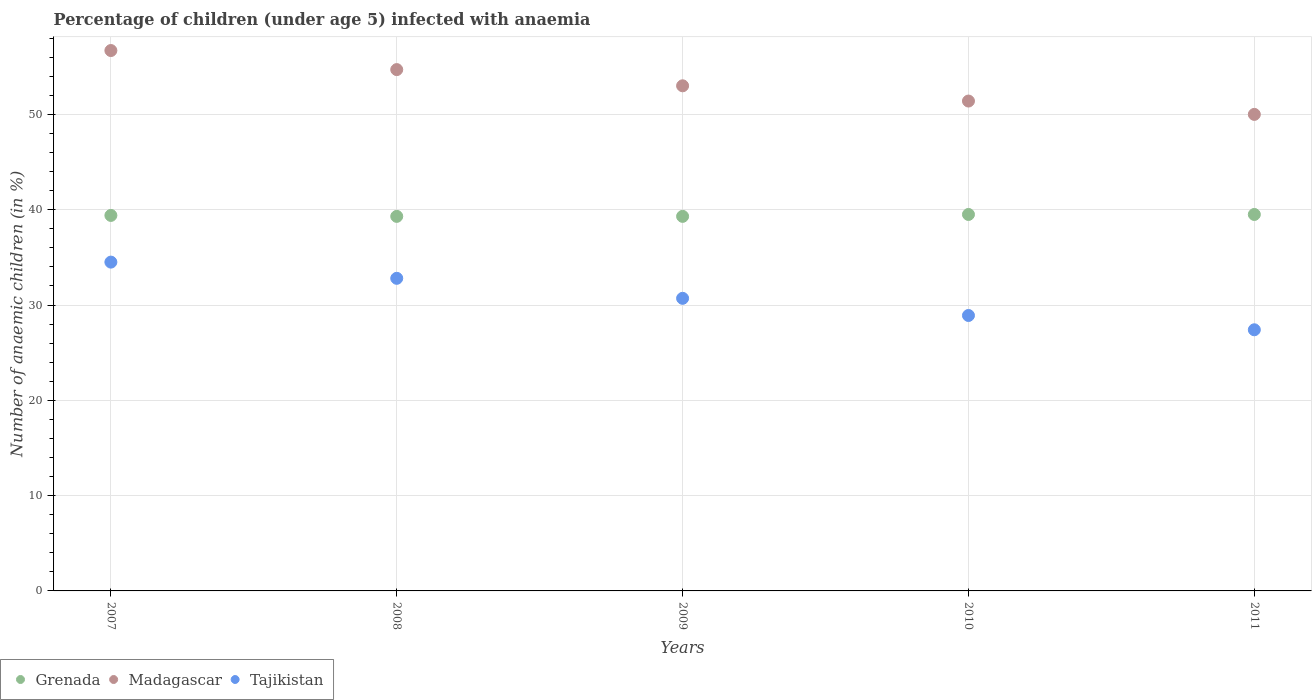How many different coloured dotlines are there?
Ensure brevity in your answer.  3. Is the number of dotlines equal to the number of legend labels?
Give a very brief answer. Yes. What is the percentage of children infected with anaemia in in Grenada in 2010?
Keep it short and to the point. 39.5. Across all years, what is the maximum percentage of children infected with anaemia in in Madagascar?
Your response must be concise. 56.7. Across all years, what is the minimum percentage of children infected with anaemia in in Madagascar?
Give a very brief answer. 50. What is the total percentage of children infected with anaemia in in Tajikistan in the graph?
Offer a terse response. 154.3. What is the difference between the percentage of children infected with anaemia in in Tajikistan in 2009 and that in 2010?
Provide a short and direct response. 1.8. What is the difference between the percentage of children infected with anaemia in in Grenada in 2007 and the percentage of children infected with anaemia in in Tajikistan in 2008?
Your answer should be compact. 6.6. What is the average percentage of children infected with anaemia in in Madagascar per year?
Ensure brevity in your answer.  53.16. In the year 2007, what is the difference between the percentage of children infected with anaemia in in Madagascar and percentage of children infected with anaemia in in Tajikistan?
Your response must be concise. 22.2. What is the ratio of the percentage of children infected with anaemia in in Madagascar in 2007 to that in 2008?
Your answer should be very brief. 1.04. Is the percentage of children infected with anaemia in in Tajikistan in 2007 less than that in 2008?
Your answer should be compact. No. Is the difference between the percentage of children infected with anaemia in in Madagascar in 2007 and 2009 greater than the difference between the percentage of children infected with anaemia in in Tajikistan in 2007 and 2009?
Make the answer very short. No. What is the difference between the highest and the lowest percentage of children infected with anaemia in in Tajikistan?
Provide a short and direct response. 7.1. Is it the case that in every year, the sum of the percentage of children infected with anaemia in in Tajikistan and percentage of children infected with anaemia in in Madagascar  is greater than the percentage of children infected with anaemia in in Grenada?
Make the answer very short. Yes. Is the percentage of children infected with anaemia in in Tajikistan strictly less than the percentage of children infected with anaemia in in Grenada over the years?
Ensure brevity in your answer.  Yes. How many years are there in the graph?
Your response must be concise. 5. What is the difference between two consecutive major ticks on the Y-axis?
Ensure brevity in your answer.  10. Are the values on the major ticks of Y-axis written in scientific E-notation?
Your answer should be very brief. No. Does the graph contain any zero values?
Your answer should be very brief. No. Does the graph contain grids?
Give a very brief answer. Yes. Where does the legend appear in the graph?
Your answer should be very brief. Bottom left. How are the legend labels stacked?
Ensure brevity in your answer.  Horizontal. What is the title of the graph?
Offer a very short reply. Percentage of children (under age 5) infected with anaemia. Does "Samoa" appear as one of the legend labels in the graph?
Provide a succinct answer. No. What is the label or title of the X-axis?
Your answer should be very brief. Years. What is the label or title of the Y-axis?
Make the answer very short. Number of anaemic children (in %). What is the Number of anaemic children (in %) in Grenada in 2007?
Ensure brevity in your answer.  39.4. What is the Number of anaemic children (in %) of Madagascar in 2007?
Offer a very short reply. 56.7. What is the Number of anaemic children (in %) of Tajikistan in 2007?
Provide a short and direct response. 34.5. What is the Number of anaemic children (in %) of Grenada in 2008?
Your answer should be compact. 39.3. What is the Number of anaemic children (in %) of Madagascar in 2008?
Offer a very short reply. 54.7. What is the Number of anaemic children (in %) of Tajikistan in 2008?
Keep it short and to the point. 32.8. What is the Number of anaemic children (in %) of Grenada in 2009?
Ensure brevity in your answer.  39.3. What is the Number of anaemic children (in %) in Tajikistan in 2009?
Keep it short and to the point. 30.7. What is the Number of anaemic children (in %) in Grenada in 2010?
Offer a very short reply. 39.5. What is the Number of anaemic children (in %) in Madagascar in 2010?
Your answer should be very brief. 51.4. What is the Number of anaemic children (in %) in Tajikistan in 2010?
Give a very brief answer. 28.9. What is the Number of anaemic children (in %) of Grenada in 2011?
Make the answer very short. 39.5. What is the Number of anaemic children (in %) in Madagascar in 2011?
Offer a very short reply. 50. What is the Number of anaemic children (in %) in Tajikistan in 2011?
Offer a terse response. 27.4. Across all years, what is the maximum Number of anaemic children (in %) of Grenada?
Provide a succinct answer. 39.5. Across all years, what is the maximum Number of anaemic children (in %) of Madagascar?
Offer a terse response. 56.7. Across all years, what is the maximum Number of anaemic children (in %) in Tajikistan?
Provide a short and direct response. 34.5. Across all years, what is the minimum Number of anaemic children (in %) of Grenada?
Keep it short and to the point. 39.3. Across all years, what is the minimum Number of anaemic children (in %) in Tajikistan?
Your response must be concise. 27.4. What is the total Number of anaemic children (in %) in Grenada in the graph?
Keep it short and to the point. 197. What is the total Number of anaemic children (in %) of Madagascar in the graph?
Give a very brief answer. 265.8. What is the total Number of anaemic children (in %) in Tajikistan in the graph?
Your response must be concise. 154.3. What is the difference between the Number of anaemic children (in %) in Grenada in 2007 and that in 2008?
Offer a very short reply. 0.1. What is the difference between the Number of anaemic children (in %) of Tajikistan in 2007 and that in 2008?
Give a very brief answer. 1.7. What is the difference between the Number of anaemic children (in %) in Grenada in 2007 and that in 2009?
Provide a short and direct response. 0.1. What is the difference between the Number of anaemic children (in %) in Tajikistan in 2007 and that in 2010?
Provide a succinct answer. 5.6. What is the difference between the Number of anaemic children (in %) of Madagascar in 2007 and that in 2011?
Ensure brevity in your answer.  6.7. What is the difference between the Number of anaemic children (in %) in Tajikistan in 2007 and that in 2011?
Ensure brevity in your answer.  7.1. What is the difference between the Number of anaemic children (in %) of Grenada in 2008 and that in 2009?
Ensure brevity in your answer.  0. What is the difference between the Number of anaemic children (in %) of Madagascar in 2008 and that in 2009?
Offer a very short reply. 1.7. What is the difference between the Number of anaemic children (in %) in Tajikistan in 2008 and that in 2009?
Offer a terse response. 2.1. What is the difference between the Number of anaemic children (in %) in Grenada in 2008 and that in 2010?
Provide a short and direct response. -0.2. What is the difference between the Number of anaemic children (in %) of Tajikistan in 2008 and that in 2010?
Offer a very short reply. 3.9. What is the difference between the Number of anaemic children (in %) in Madagascar in 2008 and that in 2011?
Provide a succinct answer. 4.7. What is the difference between the Number of anaemic children (in %) of Tajikistan in 2008 and that in 2011?
Offer a very short reply. 5.4. What is the difference between the Number of anaemic children (in %) in Madagascar in 2009 and that in 2010?
Your answer should be compact. 1.6. What is the difference between the Number of anaemic children (in %) of Grenada in 2009 and that in 2011?
Offer a terse response. -0.2. What is the difference between the Number of anaemic children (in %) of Madagascar in 2009 and that in 2011?
Keep it short and to the point. 3. What is the difference between the Number of anaemic children (in %) of Grenada in 2010 and that in 2011?
Your response must be concise. 0. What is the difference between the Number of anaemic children (in %) in Tajikistan in 2010 and that in 2011?
Offer a very short reply. 1.5. What is the difference between the Number of anaemic children (in %) of Grenada in 2007 and the Number of anaemic children (in %) of Madagascar in 2008?
Your answer should be compact. -15.3. What is the difference between the Number of anaemic children (in %) in Madagascar in 2007 and the Number of anaemic children (in %) in Tajikistan in 2008?
Make the answer very short. 23.9. What is the difference between the Number of anaemic children (in %) of Grenada in 2007 and the Number of anaemic children (in %) of Tajikistan in 2009?
Your answer should be compact. 8.7. What is the difference between the Number of anaemic children (in %) in Madagascar in 2007 and the Number of anaemic children (in %) in Tajikistan in 2009?
Keep it short and to the point. 26. What is the difference between the Number of anaemic children (in %) in Grenada in 2007 and the Number of anaemic children (in %) in Madagascar in 2010?
Your answer should be compact. -12. What is the difference between the Number of anaemic children (in %) in Madagascar in 2007 and the Number of anaemic children (in %) in Tajikistan in 2010?
Your answer should be very brief. 27.8. What is the difference between the Number of anaemic children (in %) of Grenada in 2007 and the Number of anaemic children (in %) of Madagascar in 2011?
Offer a terse response. -10.6. What is the difference between the Number of anaemic children (in %) in Madagascar in 2007 and the Number of anaemic children (in %) in Tajikistan in 2011?
Give a very brief answer. 29.3. What is the difference between the Number of anaemic children (in %) in Grenada in 2008 and the Number of anaemic children (in %) in Madagascar in 2009?
Your answer should be very brief. -13.7. What is the difference between the Number of anaemic children (in %) in Grenada in 2008 and the Number of anaemic children (in %) in Tajikistan in 2009?
Your answer should be very brief. 8.6. What is the difference between the Number of anaemic children (in %) in Madagascar in 2008 and the Number of anaemic children (in %) in Tajikistan in 2009?
Provide a succinct answer. 24. What is the difference between the Number of anaemic children (in %) in Madagascar in 2008 and the Number of anaemic children (in %) in Tajikistan in 2010?
Make the answer very short. 25.8. What is the difference between the Number of anaemic children (in %) in Grenada in 2008 and the Number of anaemic children (in %) in Madagascar in 2011?
Provide a short and direct response. -10.7. What is the difference between the Number of anaemic children (in %) in Madagascar in 2008 and the Number of anaemic children (in %) in Tajikistan in 2011?
Keep it short and to the point. 27.3. What is the difference between the Number of anaemic children (in %) in Grenada in 2009 and the Number of anaemic children (in %) in Tajikistan in 2010?
Provide a succinct answer. 10.4. What is the difference between the Number of anaemic children (in %) of Madagascar in 2009 and the Number of anaemic children (in %) of Tajikistan in 2010?
Give a very brief answer. 24.1. What is the difference between the Number of anaemic children (in %) in Grenada in 2009 and the Number of anaemic children (in %) in Madagascar in 2011?
Keep it short and to the point. -10.7. What is the difference between the Number of anaemic children (in %) of Grenada in 2009 and the Number of anaemic children (in %) of Tajikistan in 2011?
Your response must be concise. 11.9. What is the difference between the Number of anaemic children (in %) in Madagascar in 2009 and the Number of anaemic children (in %) in Tajikistan in 2011?
Offer a very short reply. 25.6. What is the average Number of anaemic children (in %) in Grenada per year?
Offer a terse response. 39.4. What is the average Number of anaemic children (in %) in Madagascar per year?
Make the answer very short. 53.16. What is the average Number of anaemic children (in %) of Tajikistan per year?
Your response must be concise. 30.86. In the year 2007, what is the difference between the Number of anaemic children (in %) of Grenada and Number of anaemic children (in %) of Madagascar?
Keep it short and to the point. -17.3. In the year 2007, what is the difference between the Number of anaemic children (in %) of Grenada and Number of anaemic children (in %) of Tajikistan?
Your answer should be compact. 4.9. In the year 2007, what is the difference between the Number of anaemic children (in %) in Madagascar and Number of anaemic children (in %) in Tajikistan?
Your answer should be compact. 22.2. In the year 2008, what is the difference between the Number of anaemic children (in %) in Grenada and Number of anaemic children (in %) in Madagascar?
Keep it short and to the point. -15.4. In the year 2008, what is the difference between the Number of anaemic children (in %) in Madagascar and Number of anaemic children (in %) in Tajikistan?
Ensure brevity in your answer.  21.9. In the year 2009, what is the difference between the Number of anaemic children (in %) of Grenada and Number of anaemic children (in %) of Madagascar?
Offer a terse response. -13.7. In the year 2009, what is the difference between the Number of anaemic children (in %) of Grenada and Number of anaemic children (in %) of Tajikistan?
Give a very brief answer. 8.6. In the year 2009, what is the difference between the Number of anaemic children (in %) of Madagascar and Number of anaemic children (in %) of Tajikistan?
Ensure brevity in your answer.  22.3. In the year 2010, what is the difference between the Number of anaemic children (in %) of Grenada and Number of anaemic children (in %) of Madagascar?
Your answer should be compact. -11.9. In the year 2010, what is the difference between the Number of anaemic children (in %) of Grenada and Number of anaemic children (in %) of Tajikistan?
Offer a very short reply. 10.6. In the year 2010, what is the difference between the Number of anaemic children (in %) of Madagascar and Number of anaemic children (in %) of Tajikistan?
Provide a short and direct response. 22.5. In the year 2011, what is the difference between the Number of anaemic children (in %) of Madagascar and Number of anaemic children (in %) of Tajikistan?
Your answer should be very brief. 22.6. What is the ratio of the Number of anaemic children (in %) of Madagascar in 2007 to that in 2008?
Your response must be concise. 1.04. What is the ratio of the Number of anaemic children (in %) of Tajikistan in 2007 to that in 2008?
Your answer should be very brief. 1.05. What is the ratio of the Number of anaemic children (in %) of Madagascar in 2007 to that in 2009?
Make the answer very short. 1.07. What is the ratio of the Number of anaemic children (in %) of Tajikistan in 2007 to that in 2009?
Offer a very short reply. 1.12. What is the ratio of the Number of anaemic children (in %) in Madagascar in 2007 to that in 2010?
Your answer should be compact. 1.1. What is the ratio of the Number of anaemic children (in %) in Tajikistan in 2007 to that in 2010?
Your answer should be compact. 1.19. What is the ratio of the Number of anaemic children (in %) in Madagascar in 2007 to that in 2011?
Give a very brief answer. 1.13. What is the ratio of the Number of anaemic children (in %) in Tajikistan in 2007 to that in 2011?
Make the answer very short. 1.26. What is the ratio of the Number of anaemic children (in %) in Madagascar in 2008 to that in 2009?
Provide a short and direct response. 1.03. What is the ratio of the Number of anaemic children (in %) of Tajikistan in 2008 to that in 2009?
Offer a terse response. 1.07. What is the ratio of the Number of anaemic children (in %) in Madagascar in 2008 to that in 2010?
Make the answer very short. 1.06. What is the ratio of the Number of anaemic children (in %) in Tajikistan in 2008 to that in 2010?
Make the answer very short. 1.13. What is the ratio of the Number of anaemic children (in %) in Grenada in 2008 to that in 2011?
Provide a short and direct response. 0.99. What is the ratio of the Number of anaemic children (in %) in Madagascar in 2008 to that in 2011?
Your answer should be compact. 1.09. What is the ratio of the Number of anaemic children (in %) of Tajikistan in 2008 to that in 2011?
Offer a terse response. 1.2. What is the ratio of the Number of anaemic children (in %) of Grenada in 2009 to that in 2010?
Offer a very short reply. 0.99. What is the ratio of the Number of anaemic children (in %) in Madagascar in 2009 to that in 2010?
Your response must be concise. 1.03. What is the ratio of the Number of anaemic children (in %) in Tajikistan in 2009 to that in 2010?
Keep it short and to the point. 1.06. What is the ratio of the Number of anaemic children (in %) of Grenada in 2009 to that in 2011?
Provide a succinct answer. 0.99. What is the ratio of the Number of anaemic children (in %) in Madagascar in 2009 to that in 2011?
Give a very brief answer. 1.06. What is the ratio of the Number of anaemic children (in %) of Tajikistan in 2009 to that in 2011?
Make the answer very short. 1.12. What is the ratio of the Number of anaemic children (in %) of Grenada in 2010 to that in 2011?
Provide a short and direct response. 1. What is the ratio of the Number of anaemic children (in %) of Madagascar in 2010 to that in 2011?
Keep it short and to the point. 1.03. What is the ratio of the Number of anaemic children (in %) in Tajikistan in 2010 to that in 2011?
Make the answer very short. 1.05. What is the difference between the highest and the second highest Number of anaemic children (in %) in Madagascar?
Provide a short and direct response. 2. What is the difference between the highest and the second highest Number of anaemic children (in %) in Tajikistan?
Your answer should be very brief. 1.7. What is the difference between the highest and the lowest Number of anaemic children (in %) of Grenada?
Provide a short and direct response. 0.2. What is the difference between the highest and the lowest Number of anaemic children (in %) in Tajikistan?
Offer a terse response. 7.1. 